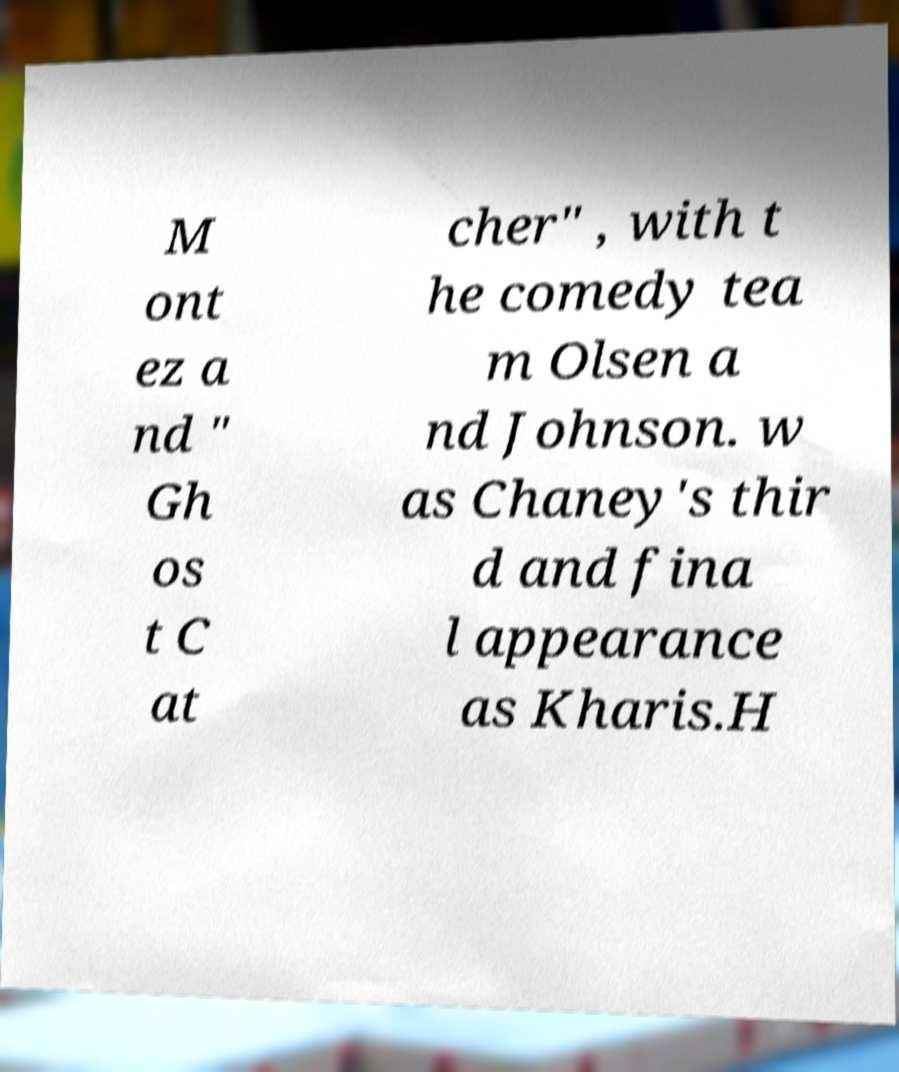Could you assist in decoding the text presented in this image and type it out clearly? M ont ez a nd " Gh os t C at cher" , with t he comedy tea m Olsen a nd Johnson. w as Chaney's thir d and fina l appearance as Kharis.H 